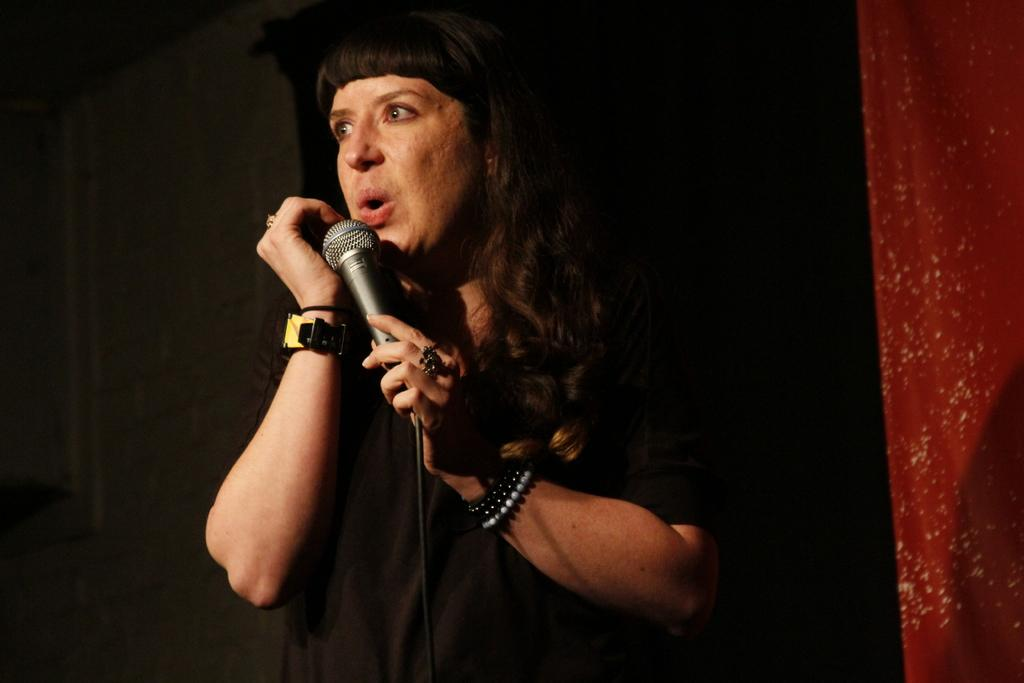Who or what is the main subject in the image? There is a person in the image. What is the person holding in the image? The person is holding a microphone. What else can be seen in the image besides the person? There are bands visible in the image. Can you describe any accessories the person is wearing? The person is wearing a watch on their hand. What is the price of the space station in the image? There is no space station present in the image, and therefore no price can be determined. 